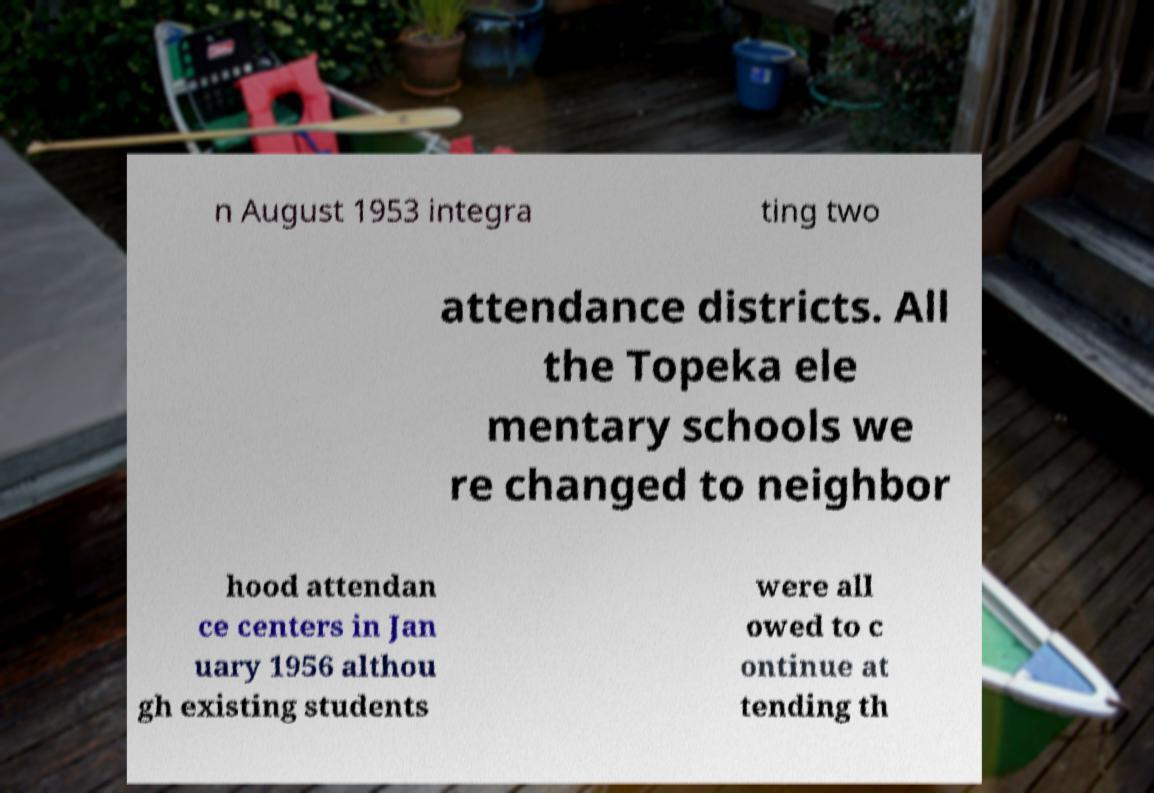Could you extract and type out the text from this image? n August 1953 integra ting two attendance districts. All the Topeka ele mentary schools we re changed to neighbor hood attendan ce centers in Jan uary 1956 althou gh existing students were all owed to c ontinue at tending th 